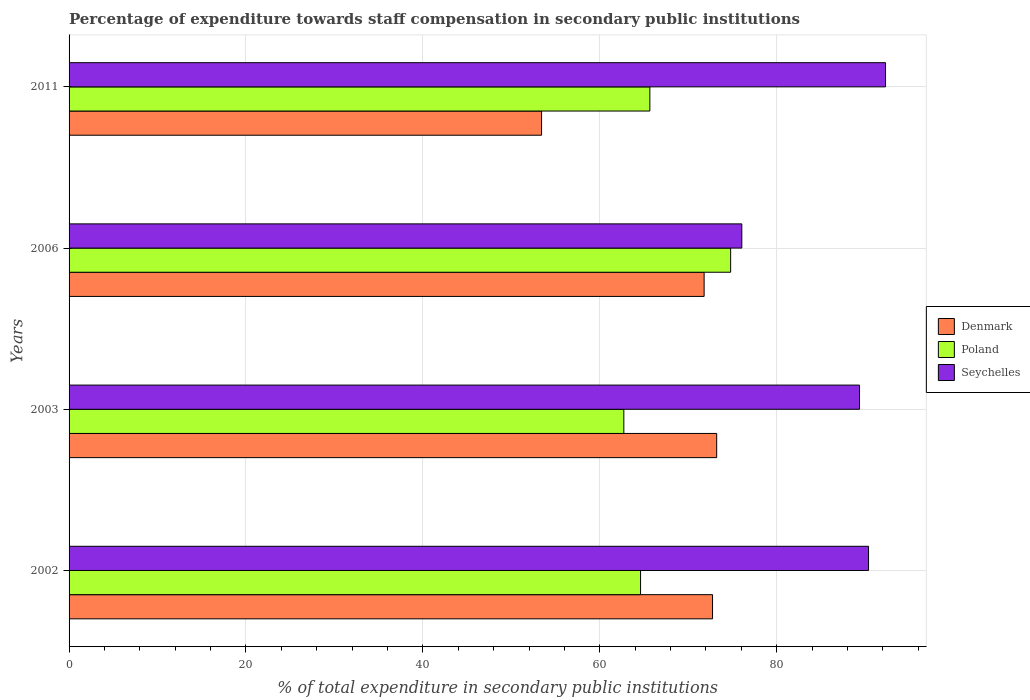How many different coloured bars are there?
Your response must be concise. 3. How many groups of bars are there?
Offer a very short reply. 4. What is the label of the 4th group of bars from the top?
Your response must be concise. 2002. What is the percentage of expenditure towards staff compensation in Seychelles in 2003?
Keep it short and to the point. 89.36. Across all years, what is the maximum percentage of expenditure towards staff compensation in Seychelles?
Offer a very short reply. 92.3. Across all years, what is the minimum percentage of expenditure towards staff compensation in Poland?
Your response must be concise. 62.72. In which year was the percentage of expenditure towards staff compensation in Poland maximum?
Give a very brief answer. 2006. What is the total percentage of expenditure towards staff compensation in Denmark in the graph?
Keep it short and to the point. 271.17. What is the difference between the percentage of expenditure towards staff compensation in Denmark in 2002 and that in 2011?
Give a very brief answer. 19.33. What is the difference between the percentage of expenditure towards staff compensation in Seychelles in 2006 and the percentage of expenditure towards staff compensation in Poland in 2011?
Your response must be concise. 10.4. What is the average percentage of expenditure towards staff compensation in Poland per year?
Your response must be concise. 66.94. In the year 2011, what is the difference between the percentage of expenditure towards staff compensation in Denmark and percentage of expenditure towards staff compensation in Seychelles?
Provide a short and direct response. -38.89. What is the ratio of the percentage of expenditure towards staff compensation in Poland in 2003 to that in 2006?
Offer a very short reply. 0.84. Is the percentage of expenditure towards staff compensation in Poland in 2002 less than that in 2006?
Provide a succinct answer. Yes. Is the difference between the percentage of expenditure towards staff compensation in Denmark in 2002 and 2006 greater than the difference between the percentage of expenditure towards staff compensation in Seychelles in 2002 and 2006?
Make the answer very short. No. What is the difference between the highest and the second highest percentage of expenditure towards staff compensation in Denmark?
Offer a very short reply. 0.47. What is the difference between the highest and the lowest percentage of expenditure towards staff compensation in Seychelles?
Your answer should be very brief. 16.25. Is the sum of the percentage of expenditure towards staff compensation in Seychelles in 2002 and 2006 greater than the maximum percentage of expenditure towards staff compensation in Poland across all years?
Ensure brevity in your answer.  Yes. What does the 1st bar from the top in 2002 represents?
Your answer should be compact. Seychelles. Is it the case that in every year, the sum of the percentage of expenditure towards staff compensation in Poland and percentage of expenditure towards staff compensation in Denmark is greater than the percentage of expenditure towards staff compensation in Seychelles?
Give a very brief answer. Yes. How many bars are there?
Provide a succinct answer. 12. Are all the bars in the graph horizontal?
Offer a very short reply. Yes. What is the difference between two consecutive major ticks on the X-axis?
Keep it short and to the point. 20. Does the graph contain any zero values?
Give a very brief answer. No. Does the graph contain grids?
Provide a succinct answer. Yes. Where does the legend appear in the graph?
Offer a terse response. Center right. How many legend labels are there?
Provide a short and direct response. 3. What is the title of the graph?
Give a very brief answer. Percentage of expenditure towards staff compensation in secondary public institutions. What is the label or title of the X-axis?
Your answer should be very brief. % of total expenditure in secondary public institutions. What is the % of total expenditure in secondary public institutions of Denmark in 2002?
Keep it short and to the point. 72.74. What is the % of total expenditure in secondary public institutions of Poland in 2002?
Ensure brevity in your answer.  64.61. What is the % of total expenditure in secondary public institutions of Seychelles in 2002?
Provide a succinct answer. 90.38. What is the % of total expenditure in secondary public institutions of Denmark in 2003?
Offer a terse response. 73.21. What is the % of total expenditure in secondary public institutions in Poland in 2003?
Your answer should be compact. 62.72. What is the % of total expenditure in secondary public institutions in Seychelles in 2003?
Give a very brief answer. 89.36. What is the % of total expenditure in secondary public institutions in Denmark in 2006?
Offer a very short reply. 71.79. What is the % of total expenditure in secondary public institutions in Poland in 2006?
Your answer should be very brief. 74.79. What is the % of total expenditure in secondary public institutions in Seychelles in 2006?
Your response must be concise. 76.06. What is the % of total expenditure in secondary public institutions in Denmark in 2011?
Ensure brevity in your answer.  53.42. What is the % of total expenditure in secondary public institutions in Poland in 2011?
Your answer should be compact. 65.66. What is the % of total expenditure in secondary public institutions of Seychelles in 2011?
Your answer should be very brief. 92.3. Across all years, what is the maximum % of total expenditure in secondary public institutions in Denmark?
Your answer should be compact. 73.21. Across all years, what is the maximum % of total expenditure in secondary public institutions in Poland?
Keep it short and to the point. 74.79. Across all years, what is the maximum % of total expenditure in secondary public institutions in Seychelles?
Provide a short and direct response. 92.3. Across all years, what is the minimum % of total expenditure in secondary public institutions of Denmark?
Keep it short and to the point. 53.42. Across all years, what is the minimum % of total expenditure in secondary public institutions in Poland?
Your response must be concise. 62.72. Across all years, what is the minimum % of total expenditure in secondary public institutions of Seychelles?
Your response must be concise. 76.06. What is the total % of total expenditure in secondary public institutions in Denmark in the graph?
Keep it short and to the point. 271.17. What is the total % of total expenditure in secondary public institutions in Poland in the graph?
Provide a short and direct response. 267.77. What is the total % of total expenditure in secondary public institutions in Seychelles in the graph?
Your response must be concise. 348.1. What is the difference between the % of total expenditure in secondary public institutions in Denmark in 2002 and that in 2003?
Keep it short and to the point. -0.47. What is the difference between the % of total expenditure in secondary public institutions of Poland in 2002 and that in 2003?
Make the answer very short. 1.89. What is the difference between the % of total expenditure in secondary public institutions in Seychelles in 2002 and that in 2003?
Give a very brief answer. 1.02. What is the difference between the % of total expenditure in secondary public institutions of Denmark in 2002 and that in 2006?
Give a very brief answer. 0.95. What is the difference between the % of total expenditure in secondary public institutions in Poland in 2002 and that in 2006?
Provide a short and direct response. -10.18. What is the difference between the % of total expenditure in secondary public institutions in Seychelles in 2002 and that in 2006?
Offer a terse response. 14.33. What is the difference between the % of total expenditure in secondary public institutions in Denmark in 2002 and that in 2011?
Your answer should be compact. 19.33. What is the difference between the % of total expenditure in secondary public institutions in Poland in 2002 and that in 2011?
Make the answer very short. -1.05. What is the difference between the % of total expenditure in secondary public institutions of Seychelles in 2002 and that in 2011?
Give a very brief answer. -1.92. What is the difference between the % of total expenditure in secondary public institutions of Denmark in 2003 and that in 2006?
Provide a succinct answer. 1.42. What is the difference between the % of total expenditure in secondary public institutions in Poland in 2003 and that in 2006?
Give a very brief answer. -12.07. What is the difference between the % of total expenditure in secondary public institutions of Seychelles in 2003 and that in 2006?
Give a very brief answer. 13.31. What is the difference between the % of total expenditure in secondary public institutions in Denmark in 2003 and that in 2011?
Offer a very short reply. 19.8. What is the difference between the % of total expenditure in secondary public institutions in Poland in 2003 and that in 2011?
Offer a terse response. -2.94. What is the difference between the % of total expenditure in secondary public institutions of Seychelles in 2003 and that in 2011?
Keep it short and to the point. -2.94. What is the difference between the % of total expenditure in secondary public institutions in Denmark in 2006 and that in 2011?
Your answer should be very brief. 18.38. What is the difference between the % of total expenditure in secondary public institutions in Poland in 2006 and that in 2011?
Give a very brief answer. 9.13. What is the difference between the % of total expenditure in secondary public institutions in Seychelles in 2006 and that in 2011?
Offer a very short reply. -16.25. What is the difference between the % of total expenditure in secondary public institutions in Denmark in 2002 and the % of total expenditure in secondary public institutions in Poland in 2003?
Ensure brevity in your answer.  10.03. What is the difference between the % of total expenditure in secondary public institutions in Denmark in 2002 and the % of total expenditure in secondary public institutions in Seychelles in 2003?
Provide a short and direct response. -16.62. What is the difference between the % of total expenditure in secondary public institutions in Poland in 2002 and the % of total expenditure in secondary public institutions in Seychelles in 2003?
Keep it short and to the point. -24.75. What is the difference between the % of total expenditure in secondary public institutions of Denmark in 2002 and the % of total expenditure in secondary public institutions of Poland in 2006?
Ensure brevity in your answer.  -2.05. What is the difference between the % of total expenditure in secondary public institutions of Denmark in 2002 and the % of total expenditure in secondary public institutions of Seychelles in 2006?
Give a very brief answer. -3.31. What is the difference between the % of total expenditure in secondary public institutions of Poland in 2002 and the % of total expenditure in secondary public institutions of Seychelles in 2006?
Keep it short and to the point. -11.45. What is the difference between the % of total expenditure in secondary public institutions in Denmark in 2002 and the % of total expenditure in secondary public institutions in Poland in 2011?
Provide a short and direct response. 7.09. What is the difference between the % of total expenditure in secondary public institutions in Denmark in 2002 and the % of total expenditure in secondary public institutions in Seychelles in 2011?
Give a very brief answer. -19.56. What is the difference between the % of total expenditure in secondary public institutions in Poland in 2002 and the % of total expenditure in secondary public institutions in Seychelles in 2011?
Keep it short and to the point. -27.69. What is the difference between the % of total expenditure in secondary public institutions in Denmark in 2003 and the % of total expenditure in secondary public institutions in Poland in 2006?
Offer a terse response. -1.58. What is the difference between the % of total expenditure in secondary public institutions in Denmark in 2003 and the % of total expenditure in secondary public institutions in Seychelles in 2006?
Offer a very short reply. -2.84. What is the difference between the % of total expenditure in secondary public institutions in Poland in 2003 and the % of total expenditure in secondary public institutions in Seychelles in 2006?
Give a very brief answer. -13.34. What is the difference between the % of total expenditure in secondary public institutions in Denmark in 2003 and the % of total expenditure in secondary public institutions in Poland in 2011?
Make the answer very short. 7.55. What is the difference between the % of total expenditure in secondary public institutions in Denmark in 2003 and the % of total expenditure in secondary public institutions in Seychelles in 2011?
Your response must be concise. -19.09. What is the difference between the % of total expenditure in secondary public institutions in Poland in 2003 and the % of total expenditure in secondary public institutions in Seychelles in 2011?
Ensure brevity in your answer.  -29.59. What is the difference between the % of total expenditure in secondary public institutions of Denmark in 2006 and the % of total expenditure in secondary public institutions of Poland in 2011?
Offer a very short reply. 6.14. What is the difference between the % of total expenditure in secondary public institutions of Denmark in 2006 and the % of total expenditure in secondary public institutions of Seychelles in 2011?
Your response must be concise. -20.51. What is the difference between the % of total expenditure in secondary public institutions in Poland in 2006 and the % of total expenditure in secondary public institutions in Seychelles in 2011?
Your response must be concise. -17.51. What is the average % of total expenditure in secondary public institutions in Denmark per year?
Your answer should be compact. 67.79. What is the average % of total expenditure in secondary public institutions of Poland per year?
Provide a short and direct response. 66.94. What is the average % of total expenditure in secondary public institutions in Seychelles per year?
Your answer should be compact. 87.02. In the year 2002, what is the difference between the % of total expenditure in secondary public institutions in Denmark and % of total expenditure in secondary public institutions in Poland?
Offer a terse response. 8.14. In the year 2002, what is the difference between the % of total expenditure in secondary public institutions of Denmark and % of total expenditure in secondary public institutions of Seychelles?
Your answer should be very brief. -17.64. In the year 2002, what is the difference between the % of total expenditure in secondary public institutions in Poland and % of total expenditure in secondary public institutions in Seychelles?
Your answer should be very brief. -25.77. In the year 2003, what is the difference between the % of total expenditure in secondary public institutions of Denmark and % of total expenditure in secondary public institutions of Poland?
Provide a succinct answer. 10.5. In the year 2003, what is the difference between the % of total expenditure in secondary public institutions in Denmark and % of total expenditure in secondary public institutions in Seychelles?
Offer a terse response. -16.15. In the year 2003, what is the difference between the % of total expenditure in secondary public institutions of Poland and % of total expenditure in secondary public institutions of Seychelles?
Offer a terse response. -26.65. In the year 2006, what is the difference between the % of total expenditure in secondary public institutions in Denmark and % of total expenditure in secondary public institutions in Poland?
Ensure brevity in your answer.  -3. In the year 2006, what is the difference between the % of total expenditure in secondary public institutions in Denmark and % of total expenditure in secondary public institutions in Seychelles?
Provide a short and direct response. -4.26. In the year 2006, what is the difference between the % of total expenditure in secondary public institutions in Poland and % of total expenditure in secondary public institutions in Seychelles?
Your response must be concise. -1.26. In the year 2011, what is the difference between the % of total expenditure in secondary public institutions of Denmark and % of total expenditure in secondary public institutions of Poland?
Keep it short and to the point. -12.24. In the year 2011, what is the difference between the % of total expenditure in secondary public institutions of Denmark and % of total expenditure in secondary public institutions of Seychelles?
Your response must be concise. -38.89. In the year 2011, what is the difference between the % of total expenditure in secondary public institutions of Poland and % of total expenditure in secondary public institutions of Seychelles?
Keep it short and to the point. -26.64. What is the ratio of the % of total expenditure in secondary public institutions of Denmark in 2002 to that in 2003?
Give a very brief answer. 0.99. What is the ratio of the % of total expenditure in secondary public institutions of Poland in 2002 to that in 2003?
Offer a very short reply. 1.03. What is the ratio of the % of total expenditure in secondary public institutions in Seychelles in 2002 to that in 2003?
Provide a short and direct response. 1.01. What is the ratio of the % of total expenditure in secondary public institutions of Denmark in 2002 to that in 2006?
Ensure brevity in your answer.  1.01. What is the ratio of the % of total expenditure in secondary public institutions in Poland in 2002 to that in 2006?
Give a very brief answer. 0.86. What is the ratio of the % of total expenditure in secondary public institutions of Seychelles in 2002 to that in 2006?
Make the answer very short. 1.19. What is the ratio of the % of total expenditure in secondary public institutions in Denmark in 2002 to that in 2011?
Ensure brevity in your answer.  1.36. What is the ratio of the % of total expenditure in secondary public institutions in Seychelles in 2002 to that in 2011?
Your response must be concise. 0.98. What is the ratio of the % of total expenditure in secondary public institutions of Denmark in 2003 to that in 2006?
Offer a terse response. 1.02. What is the ratio of the % of total expenditure in secondary public institutions of Poland in 2003 to that in 2006?
Make the answer very short. 0.84. What is the ratio of the % of total expenditure in secondary public institutions of Seychelles in 2003 to that in 2006?
Make the answer very short. 1.18. What is the ratio of the % of total expenditure in secondary public institutions of Denmark in 2003 to that in 2011?
Keep it short and to the point. 1.37. What is the ratio of the % of total expenditure in secondary public institutions in Poland in 2003 to that in 2011?
Keep it short and to the point. 0.96. What is the ratio of the % of total expenditure in secondary public institutions in Seychelles in 2003 to that in 2011?
Offer a very short reply. 0.97. What is the ratio of the % of total expenditure in secondary public institutions in Denmark in 2006 to that in 2011?
Give a very brief answer. 1.34. What is the ratio of the % of total expenditure in secondary public institutions of Poland in 2006 to that in 2011?
Provide a succinct answer. 1.14. What is the ratio of the % of total expenditure in secondary public institutions of Seychelles in 2006 to that in 2011?
Make the answer very short. 0.82. What is the difference between the highest and the second highest % of total expenditure in secondary public institutions in Denmark?
Provide a short and direct response. 0.47. What is the difference between the highest and the second highest % of total expenditure in secondary public institutions of Poland?
Your response must be concise. 9.13. What is the difference between the highest and the second highest % of total expenditure in secondary public institutions in Seychelles?
Ensure brevity in your answer.  1.92. What is the difference between the highest and the lowest % of total expenditure in secondary public institutions in Denmark?
Give a very brief answer. 19.8. What is the difference between the highest and the lowest % of total expenditure in secondary public institutions in Poland?
Your answer should be very brief. 12.07. What is the difference between the highest and the lowest % of total expenditure in secondary public institutions of Seychelles?
Offer a very short reply. 16.25. 